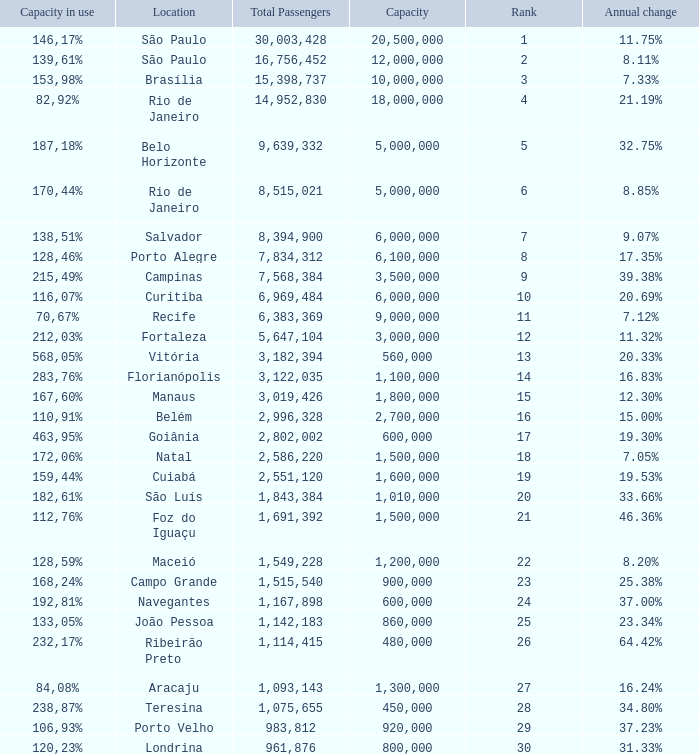What location has an in use capacity of 167,60%? 1800000.0. 